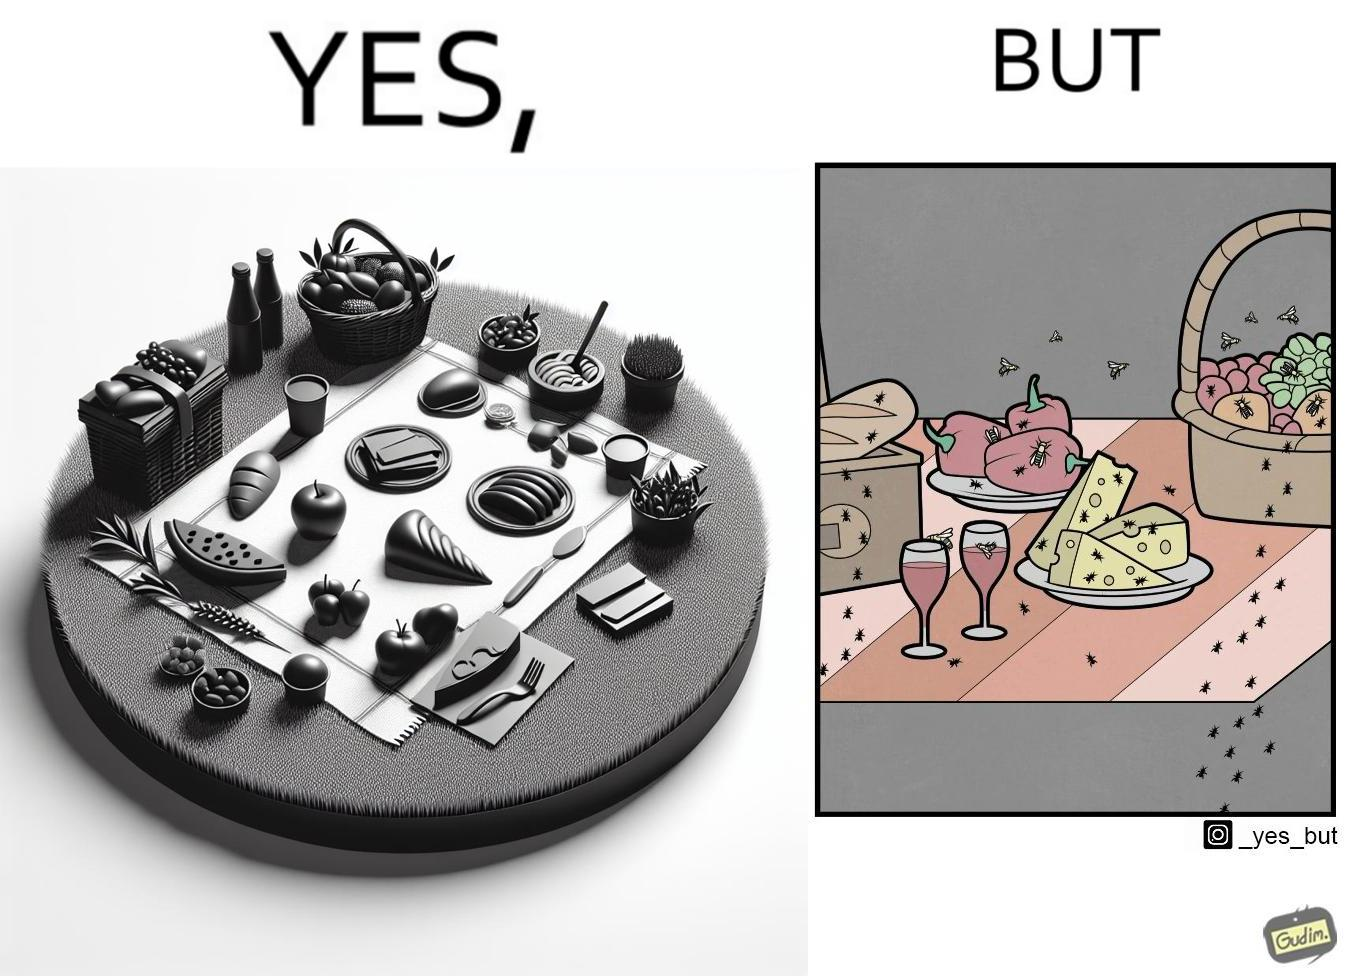Is this a satirical image? Yes, this image is satirical. 